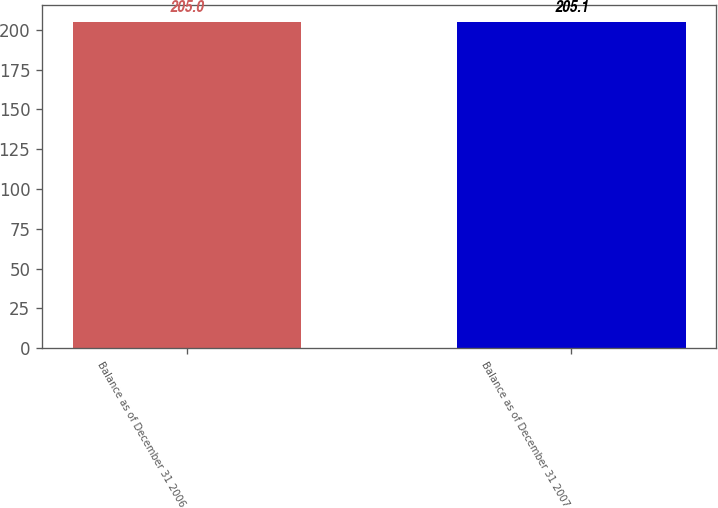<chart> <loc_0><loc_0><loc_500><loc_500><bar_chart><fcel>Balance as of December 31 2006<fcel>Balance as of December 31 2007<nl><fcel>205<fcel>205.1<nl></chart> 